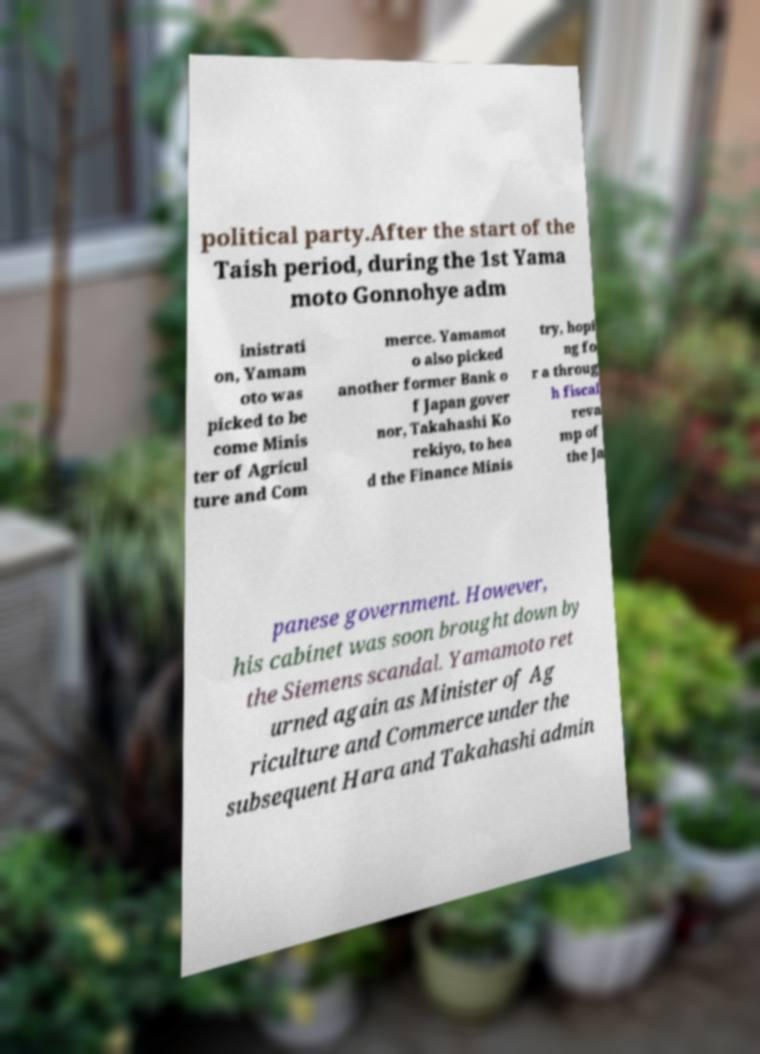Could you assist in decoding the text presented in this image and type it out clearly? political party.After the start of the Taish period, during the 1st Yama moto Gonnohye adm inistrati on, Yamam oto was picked to be come Minis ter of Agricul ture and Com merce. Yamamot o also picked another former Bank o f Japan gover nor, Takahashi Ko rekiyo, to hea d the Finance Minis try, hopi ng fo r a throug h fiscal reva mp of the Ja panese government. However, his cabinet was soon brought down by the Siemens scandal. Yamamoto ret urned again as Minister of Ag riculture and Commerce under the subsequent Hara and Takahashi admin 